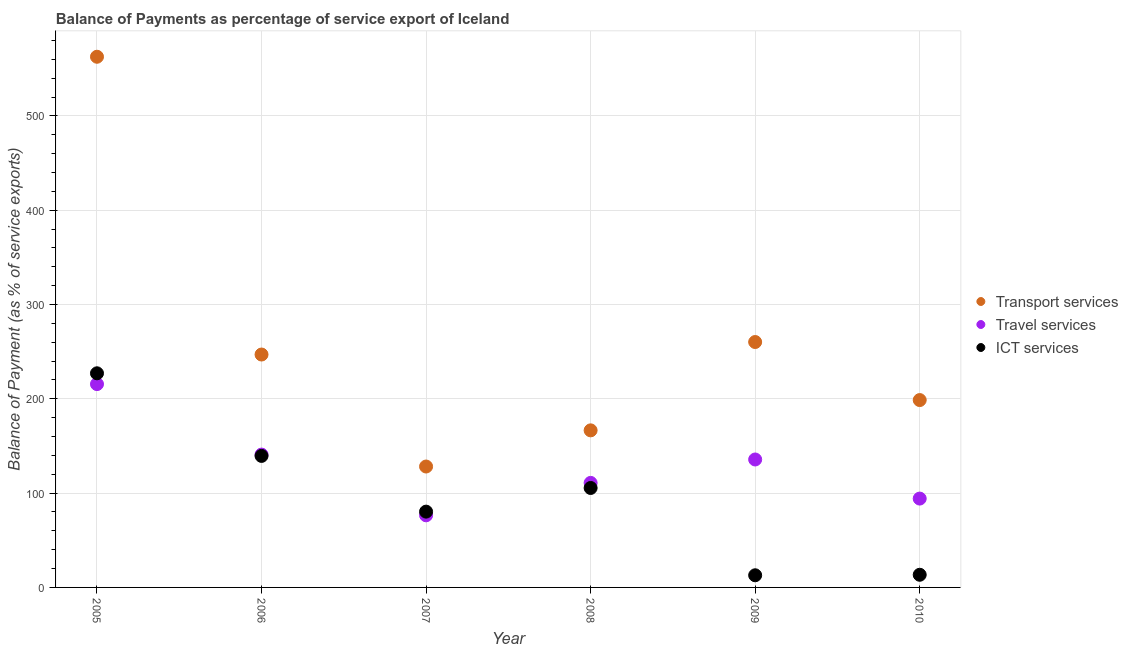How many different coloured dotlines are there?
Your answer should be very brief. 3. Is the number of dotlines equal to the number of legend labels?
Make the answer very short. Yes. What is the balance of payment of ict services in 2006?
Keep it short and to the point. 139.47. Across all years, what is the maximum balance of payment of transport services?
Give a very brief answer. 562.81. Across all years, what is the minimum balance of payment of travel services?
Offer a very short reply. 76.47. What is the total balance of payment of travel services in the graph?
Make the answer very short. 773.76. What is the difference between the balance of payment of ict services in 2008 and that in 2009?
Provide a short and direct response. 92.59. What is the difference between the balance of payment of ict services in 2007 and the balance of payment of travel services in 2008?
Provide a succinct answer. -30.48. What is the average balance of payment of ict services per year?
Your answer should be compact. 96.46. In the year 2010, what is the difference between the balance of payment of ict services and balance of payment of travel services?
Your answer should be compact. -80.8. In how many years, is the balance of payment of travel services greater than 100 %?
Your response must be concise. 4. What is the ratio of the balance of payment of transport services in 2006 to that in 2010?
Your response must be concise. 1.24. What is the difference between the highest and the second highest balance of payment of travel services?
Give a very brief answer. 74.77. What is the difference between the highest and the lowest balance of payment of travel services?
Keep it short and to the point. 139.18. In how many years, is the balance of payment of travel services greater than the average balance of payment of travel services taken over all years?
Keep it short and to the point. 3. How many dotlines are there?
Offer a very short reply. 3. How many years are there in the graph?
Offer a terse response. 6. What is the difference between two consecutive major ticks on the Y-axis?
Your answer should be very brief. 100. Does the graph contain grids?
Provide a short and direct response. Yes. How many legend labels are there?
Keep it short and to the point. 3. How are the legend labels stacked?
Keep it short and to the point. Vertical. What is the title of the graph?
Keep it short and to the point. Balance of Payments as percentage of service export of Iceland. Does "Argument" appear as one of the legend labels in the graph?
Keep it short and to the point. No. What is the label or title of the Y-axis?
Offer a terse response. Balance of Payment (as % of service exports). What is the Balance of Payment (as % of service exports) in Transport services in 2005?
Offer a very short reply. 562.81. What is the Balance of Payment (as % of service exports) in Travel services in 2005?
Keep it short and to the point. 215.64. What is the Balance of Payment (as % of service exports) of ICT services in 2005?
Provide a succinct answer. 227.09. What is the Balance of Payment (as % of service exports) of Transport services in 2006?
Keep it short and to the point. 247. What is the Balance of Payment (as % of service exports) in Travel services in 2006?
Give a very brief answer. 140.88. What is the Balance of Payment (as % of service exports) in ICT services in 2006?
Provide a succinct answer. 139.47. What is the Balance of Payment (as % of service exports) of Transport services in 2007?
Your answer should be compact. 128.23. What is the Balance of Payment (as % of service exports) in Travel services in 2007?
Offer a terse response. 76.47. What is the Balance of Payment (as % of service exports) in ICT services in 2007?
Offer a terse response. 80.38. What is the Balance of Payment (as % of service exports) of Transport services in 2008?
Your response must be concise. 166.58. What is the Balance of Payment (as % of service exports) of Travel services in 2008?
Make the answer very short. 110.86. What is the Balance of Payment (as % of service exports) in ICT services in 2008?
Offer a very short reply. 105.47. What is the Balance of Payment (as % of service exports) in Transport services in 2009?
Give a very brief answer. 260.27. What is the Balance of Payment (as % of service exports) of Travel services in 2009?
Your response must be concise. 135.69. What is the Balance of Payment (as % of service exports) in ICT services in 2009?
Ensure brevity in your answer.  12.89. What is the Balance of Payment (as % of service exports) in Transport services in 2010?
Your answer should be very brief. 198.71. What is the Balance of Payment (as % of service exports) of Travel services in 2010?
Offer a terse response. 94.23. What is the Balance of Payment (as % of service exports) in ICT services in 2010?
Give a very brief answer. 13.43. Across all years, what is the maximum Balance of Payment (as % of service exports) of Transport services?
Offer a very short reply. 562.81. Across all years, what is the maximum Balance of Payment (as % of service exports) in Travel services?
Offer a very short reply. 215.64. Across all years, what is the maximum Balance of Payment (as % of service exports) of ICT services?
Your answer should be very brief. 227.09. Across all years, what is the minimum Balance of Payment (as % of service exports) of Transport services?
Give a very brief answer. 128.23. Across all years, what is the minimum Balance of Payment (as % of service exports) of Travel services?
Provide a succinct answer. 76.47. Across all years, what is the minimum Balance of Payment (as % of service exports) in ICT services?
Offer a very short reply. 12.89. What is the total Balance of Payment (as % of service exports) of Transport services in the graph?
Your response must be concise. 1563.59. What is the total Balance of Payment (as % of service exports) in Travel services in the graph?
Offer a terse response. 773.76. What is the total Balance of Payment (as % of service exports) of ICT services in the graph?
Keep it short and to the point. 578.74. What is the difference between the Balance of Payment (as % of service exports) of Transport services in 2005 and that in 2006?
Offer a terse response. 315.81. What is the difference between the Balance of Payment (as % of service exports) in Travel services in 2005 and that in 2006?
Provide a succinct answer. 74.77. What is the difference between the Balance of Payment (as % of service exports) of ICT services in 2005 and that in 2006?
Your answer should be very brief. 87.62. What is the difference between the Balance of Payment (as % of service exports) in Transport services in 2005 and that in 2007?
Ensure brevity in your answer.  434.58. What is the difference between the Balance of Payment (as % of service exports) in Travel services in 2005 and that in 2007?
Your response must be concise. 139.18. What is the difference between the Balance of Payment (as % of service exports) in ICT services in 2005 and that in 2007?
Keep it short and to the point. 146.71. What is the difference between the Balance of Payment (as % of service exports) in Transport services in 2005 and that in 2008?
Your answer should be very brief. 396.23. What is the difference between the Balance of Payment (as % of service exports) in Travel services in 2005 and that in 2008?
Give a very brief answer. 104.78. What is the difference between the Balance of Payment (as % of service exports) in ICT services in 2005 and that in 2008?
Your answer should be very brief. 121.62. What is the difference between the Balance of Payment (as % of service exports) in Transport services in 2005 and that in 2009?
Your answer should be compact. 302.54. What is the difference between the Balance of Payment (as % of service exports) of Travel services in 2005 and that in 2009?
Offer a very short reply. 79.96. What is the difference between the Balance of Payment (as % of service exports) in ICT services in 2005 and that in 2009?
Offer a terse response. 214.2. What is the difference between the Balance of Payment (as % of service exports) of Transport services in 2005 and that in 2010?
Provide a short and direct response. 364.1. What is the difference between the Balance of Payment (as % of service exports) in Travel services in 2005 and that in 2010?
Offer a very short reply. 121.42. What is the difference between the Balance of Payment (as % of service exports) in ICT services in 2005 and that in 2010?
Your response must be concise. 213.67. What is the difference between the Balance of Payment (as % of service exports) in Transport services in 2006 and that in 2007?
Your response must be concise. 118.77. What is the difference between the Balance of Payment (as % of service exports) of Travel services in 2006 and that in 2007?
Give a very brief answer. 64.41. What is the difference between the Balance of Payment (as % of service exports) in ICT services in 2006 and that in 2007?
Your response must be concise. 59.09. What is the difference between the Balance of Payment (as % of service exports) in Transport services in 2006 and that in 2008?
Your response must be concise. 80.42. What is the difference between the Balance of Payment (as % of service exports) in Travel services in 2006 and that in 2008?
Make the answer very short. 30.02. What is the difference between the Balance of Payment (as % of service exports) in ICT services in 2006 and that in 2008?
Provide a succinct answer. 34. What is the difference between the Balance of Payment (as % of service exports) of Transport services in 2006 and that in 2009?
Ensure brevity in your answer.  -13.27. What is the difference between the Balance of Payment (as % of service exports) of Travel services in 2006 and that in 2009?
Give a very brief answer. 5.19. What is the difference between the Balance of Payment (as % of service exports) in ICT services in 2006 and that in 2009?
Give a very brief answer. 126.59. What is the difference between the Balance of Payment (as % of service exports) of Transport services in 2006 and that in 2010?
Ensure brevity in your answer.  48.29. What is the difference between the Balance of Payment (as % of service exports) in Travel services in 2006 and that in 2010?
Provide a short and direct response. 46.65. What is the difference between the Balance of Payment (as % of service exports) in ICT services in 2006 and that in 2010?
Make the answer very short. 126.05. What is the difference between the Balance of Payment (as % of service exports) of Transport services in 2007 and that in 2008?
Your answer should be compact. -38.35. What is the difference between the Balance of Payment (as % of service exports) of Travel services in 2007 and that in 2008?
Offer a very short reply. -34.39. What is the difference between the Balance of Payment (as % of service exports) in ICT services in 2007 and that in 2008?
Offer a terse response. -25.09. What is the difference between the Balance of Payment (as % of service exports) of Transport services in 2007 and that in 2009?
Your answer should be very brief. -132.04. What is the difference between the Balance of Payment (as % of service exports) in Travel services in 2007 and that in 2009?
Your answer should be compact. -59.22. What is the difference between the Balance of Payment (as % of service exports) in ICT services in 2007 and that in 2009?
Your response must be concise. 67.5. What is the difference between the Balance of Payment (as % of service exports) in Transport services in 2007 and that in 2010?
Give a very brief answer. -70.48. What is the difference between the Balance of Payment (as % of service exports) of Travel services in 2007 and that in 2010?
Your response must be concise. -17.76. What is the difference between the Balance of Payment (as % of service exports) of ICT services in 2007 and that in 2010?
Your answer should be compact. 66.96. What is the difference between the Balance of Payment (as % of service exports) of Transport services in 2008 and that in 2009?
Your answer should be compact. -93.69. What is the difference between the Balance of Payment (as % of service exports) in Travel services in 2008 and that in 2009?
Make the answer very short. -24.83. What is the difference between the Balance of Payment (as % of service exports) in ICT services in 2008 and that in 2009?
Ensure brevity in your answer.  92.59. What is the difference between the Balance of Payment (as % of service exports) in Transport services in 2008 and that in 2010?
Offer a very short reply. -32.13. What is the difference between the Balance of Payment (as % of service exports) in Travel services in 2008 and that in 2010?
Make the answer very short. 16.63. What is the difference between the Balance of Payment (as % of service exports) in ICT services in 2008 and that in 2010?
Keep it short and to the point. 92.05. What is the difference between the Balance of Payment (as % of service exports) in Transport services in 2009 and that in 2010?
Give a very brief answer. 61.56. What is the difference between the Balance of Payment (as % of service exports) of Travel services in 2009 and that in 2010?
Your response must be concise. 41.46. What is the difference between the Balance of Payment (as % of service exports) of ICT services in 2009 and that in 2010?
Ensure brevity in your answer.  -0.54. What is the difference between the Balance of Payment (as % of service exports) in Transport services in 2005 and the Balance of Payment (as % of service exports) in Travel services in 2006?
Provide a short and direct response. 421.93. What is the difference between the Balance of Payment (as % of service exports) of Transport services in 2005 and the Balance of Payment (as % of service exports) of ICT services in 2006?
Make the answer very short. 423.33. What is the difference between the Balance of Payment (as % of service exports) of Travel services in 2005 and the Balance of Payment (as % of service exports) of ICT services in 2006?
Your answer should be very brief. 76.17. What is the difference between the Balance of Payment (as % of service exports) of Transport services in 2005 and the Balance of Payment (as % of service exports) of Travel services in 2007?
Make the answer very short. 486.34. What is the difference between the Balance of Payment (as % of service exports) of Transport services in 2005 and the Balance of Payment (as % of service exports) of ICT services in 2007?
Offer a very short reply. 482.42. What is the difference between the Balance of Payment (as % of service exports) in Travel services in 2005 and the Balance of Payment (as % of service exports) in ICT services in 2007?
Ensure brevity in your answer.  135.26. What is the difference between the Balance of Payment (as % of service exports) of Transport services in 2005 and the Balance of Payment (as % of service exports) of Travel services in 2008?
Offer a very short reply. 451.95. What is the difference between the Balance of Payment (as % of service exports) in Transport services in 2005 and the Balance of Payment (as % of service exports) in ICT services in 2008?
Ensure brevity in your answer.  457.33. What is the difference between the Balance of Payment (as % of service exports) of Travel services in 2005 and the Balance of Payment (as % of service exports) of ICT services in 2008?
Offer a very short reply. 110.17. What is the difference between the Balance of Payment (as % of service exports) of Transport services in 2005 and the Balance of Payment (as % of service exports) of Travel services in 2009?
Keep it short and to the point. 427.12. What is the difference between the Balance of Payment (as % of service exports) of Transport services in 2005 and the Balance of Payment (as % of service exports) of ICT services in 2009?
Your answer should be very brief. 549.92. What is the difference between the Balance of Payment (as % of service exports) of Travel services in 2005 and the Balance of Payment (as % of service exports) of ICT services in 2009?
Offer a terse response. 202.76. What is the difference between the Balance of Payment (as % of service exports) in Transport services in 2005 and the Balance of Payment (as % of service exports) in Travel services in 2010?
Keep it short and to the point. 468.58. What is the difference between the Balance of Payment (as % of service exports) of Transport services in 2005 and the Balance of Payment (as % of service exports) of ICT services in 2010?
Your answer should be compact. 549.38. What is the difference between the Balance of Payment (as % of service exports) of Travel services in 2005 and the Balance of Payment (as % of service exports) of ICT services in 2010?
Your answer should be very brief. 202.22. What is the difference between the Balance of Payment (as % of service exports) in Transport services in 2006 and the Balance of Payment (as % of service exports) in Travel services in 2007?
Your answer should be compact. 170.53. What is the difference between the Balance of Payment (as % of service exports) in Transport services in 2006 and the Balance of Payment (as % of service exports) in ICT services in 2007?
Ensure brevity in your answer.  166.61. What is the difference between the Balance of Payment (as % of service exports) of Travel services in 2006 and the Balance of Payment (as % of service exports) of ICT services in 2007?
Your answer should be very brief. 60.49. What is the difference between the Balance of Payment (as % of service exports) of Transport services in 2006 and the Balance of Payment (as % of service exports) of Travel services in 2008?
Your response must be concise. 136.14. What is the difference between the Balance of Payment (as % of service exports) in Transport services in 2006 and the Balance of Payment (as % of service exports) in ICT services in 2008?
Keep it short and to the point. 141.52. What is the difference between the Balance of Payment (as % of service exports) in Travel services in 2006 and the Balance of Payment (as % of service exports) in ICT services in 2008?
Your answer should be very brief. 35.4. What is the difference between the Balance of Payment (as % of service exports) in Transport services in 2006 and the Balance of Payment (as % of service exports) in Travel services in 2009?
Keep it short and to the point. 111.31. What is the difference between the Balance of Payment (as % of service exports) of Transport services in 2006 and the Balance of Payment (as % of service exports) of ICT services in 2009?
Provide a short and direct response. 234.11. What is the difference between the Balance of Payment (as % of service exports) in Travel services in 2006 and the Balance of Payment (as % of service exports) in ICT services in 2009?
Offer a terse response. 127.99. What is the difference between the Balance of Payment (as % of service exports) of Transport services in 2006 and the Balance of Payment (as % of service exports) of Travel services in 2010?
Offer a terse response. 152.77. What is the difference between the Balance of Payment (as % of service exports) of Transport services in 2006 and the Balance of Payment (as % of service exports) of ICT services in 2010?
Make the answer very short. 233.57. What is the difference between the Balance of Payment (as % of service exports) of Travel services in 2006 and the Balance of Payment (as % of service exports) of ICT services in 2010?
Give a very brief answer. 127.45. What is the difference between the Balance of Payment (as % of service exports) of Transport services in 2007 and the Balance of Payment (as % of service exports) of Travel services in 2008?
Ensure brevity in your answer.  17.37. What is the difference between the Balance of Payment (as % of service exports) of Transport services in 2007 and the Balance of Payment (as % of service exports) of ICT services in 2008?
Provide a succinct answer. 22.75. What is the difference between the Balance of Payment (as % of service exports) in Travel services in 2007 and the Balance of Payment (as % of service exports) in ICT services in 2008?
Give a very brief answer. -29.01. What is the difference between the Balance of Payment (as % of service exports) in Transport services in 2007 and the Balance of Payment (as % of service exports) in Travel services in 2009?
Provide a short and direct response. -7.46. What is the difference between the Balance of Payment (as % of service exports) in Transport services in 2007 and the Balance of Payment (as % of service exports) in ICT services in 2009?
Offer a very short reply. 115.34. What is the difference between the Balance of Payment (as % of service exports) of Travel services in 2007 and the Balance of Payment (as % of service exports) of ICT services in 2009?
Provide a short and direct response. 63.58. What is the difference between the Balance of Payment (as % of service exports) in Transport services in 2007 and the Balance of Payment (as % of service exports) in Travel services in 2010?
Provide a succinct answer. 34. What is the difference between the Balance of Payment (as % of service exports) of Transport services in 2007 and the Balance of Payment (as % of service exports) of ICT services in 2010?
Ensure brevity in your answer.  114.8. What is the difference between the Balance of Payment (as % of service exports) in Travel services in 2007 and the Balance of Payment (as % of service exports) in ICT services in 2010?
Offer a very short reply. 63.04. What is the difference between the Balance of Payment (as % of service exports) of Transport services in 2008 and the Balance of Payment (as % of service exports) of Travel services in 2009?
Provide a succinct answer. 30.9. What is the difference between the Balance of Payment (as % of service exports) of Transport services in 2008 and the Balance of Payment (as % of service exports) of ICT services in 2009?
Provide a short and direct response. 153.69. What is the difference between the Balance of Payment (as % of service exports) in Travel services in 2008 and the Balance of Payment (as % of service exports) in ICT services in 2009?
Your answer should be compact. 97.97. What is the difference between the Balance of Payment (as % of service exports) of Transport services in 2008 and the Balance of Payment (as % of service exports) of Travel services in 2010?
Make the answer very short. 72.36. What is the difference between the Balance of Payment (as % of service exports) of Transport services in 2008 and the Balance of Payment (as % of service exports) of ICT services in 2010?
Provide a succinct answer. 153.16. What is the difference between the Balance of Payment (as % of service exports) of Travel services in 2008 and the Balance of Payment (as % of service exports) of ICT services in 2010?
Offer a terse response. 97.43. What is the difference between the Balance of Payment (as % of service exports) of Transport services in 2009 and the Balance of Payment (as % of service exports) of Travel services in 2010?
Your answer should be compact. 166.04. What is the difference between the Balance of Payment (as % of service exports) of Transport services in 2009 and the Balance of Payment (as % of service exports) of ICT services in 2010?
Your answer should be compact. 246.84. What is the difference between the Balance of Payment (as % of service exports) of Travel services in 2009 and the Balance of Payment (as % of service exports) of ICT services in 2010?
Your answer should be very brief. 122.26. What is the average Balance of Payment (as % of service exports) of Transport services per year?
Give a very brief answer. 260.6. What is the average Balance of Payment (as % of service exports) of Travel services per year?
Your response must be concise. 128.96. What is the average Balance of Payment (as % of service exports) in ICT services per year?
Offer a very short reply. 96.46. In the year 2005, what is the difference between the Balance of Payment (as % of service exports) in Transport services and Balance of Payment (as % of service exports) in Travel services?
Make the answer very short. 347.16. In the year 2005, what is the difference between the Balance of Payment (as % of service exports) in Transport services and Balance of Payment (as % of service exports) in ICT services?
Your answer should be compact. 335.71. In the year 2005, what is the difference between the Balance of Payment (as % of service exports) of Travel services and Balance of Payment (as % of service exports) of ICT services?
Provide a short and direct response. -11.45. In the year 2006, what is the difference between the Balance of Payment (as % of service exports) in Transport services and Balance of Payment (as % of service exports) in Travel services?
Give a very brief answer. 106.12. In the year 2006, what is the difference between the Balance of Payment (as % of service exports) of Transport services and Balance of Payment (as % of service exports) of ICT services?
Your answer should be compact. 107.52. In the year 2006, what is the difference between the Balance of Payment (as % of service exports) of Travel services and Balance of Payment (as % of service exports) of ICT services?
Your answer should be compact. 1.4. In the year 2007, what is the difference between the Balance of Payment (as % of service exports) of Transport services and Balance of Payment (as % of service exports) of Travel services?
Keep it short and to the point. 51.76. In the year 2007, what is the difference between the Balance of Payment (as % of service exports) in Transport services and Balance of Payment (as % of service exports) in ICT services?
Ensure brevity in your answer.  47.84. In the year 2007, what is the difference between the Balance of Payment (as % of service exports) of Travel services and Balance of Payment (as % of service exports) of ICT services?
Give a very brief answer. -3.92. In the year 2008, what is the difference between the Balance of Payment (as % of service exports) of Transport services and Balance of Payment (as % of service exports) of Travel services?
Ensure brevity in your answer.  55.72. In the year 2008, what is the difference between the Balance of Payment (as % of service exports) of Transport services and Balance of Payment (as % of service exports) of ICT services?
Make the answer very short. 61.11. In the year 2008, what is the difference between the Balance of Payment (as % of service exports) of Travel services and Balance of Payment (as % of service exports) of ICT services?
Your answer should be very brief. 5.39. In the year 2009, what is the difference between the Balance of Payment (as % of service exports) in Transport services and Balance of Payment (as % of service exports) in Travel services?
Your response must be concise. 124.58. In the year 2009, what is the difference between the Balance of Payment (as % of service exports) of Transport services and Balance of Payment (as % of service exports) of ICT services?
Your answer should be compact. 247.38. In the year 2009, what is the difference between the Balance of Payment (as % of service exports) in Travel services and Balance of Payment (as % of service exports) in ICT services?
Ensure brevity in your answer.  122.8. In the year 2010, what is the difference between the Balance of Payment (as % of service exports) in Transport services and Balance of Payment (as % of service exports) in Travel services?
Provide a short and direct response. 104.48. In the year 2010, what is the difference between the Balance of Payment (as % of service exports) in Transport services and Balance of Payment (as % of service exports) in ICT services?
Provide a succinct answer. 185.28. In the year 2010, what is the difference between the Balance of Payment (as % of service exports) of Travel services and Balance of Payment (as % of service exports) of ICT services?
Provide a succinct answer. 80.8. What is the ratio of the Balance of Payment (as % of service exports) of Transport services in 2005 to that in 2006?
Your answer should be compact. 2.28. What is the ratio of the Balance of Payment (as % of service exports) of Travel services in 2005 to that in 2006?
Your answer should be compact. 1.53. What is the ratio of the Balance of Payment (as % of service exports) in ICT services in 2005 to that in 2006?
Your answer should be very brief. 1.63. What is the ratio of the Balance of Payment (as % of service exports) of Transport services in 2005 to that in 2007?
Make the answer very short. 4.39. What is the ratio of the Balance of Payment (as % of service exports) of Travel services in 2005 to that in 2007?
Your answer should be compact. 2.82. What is the ratio of the Balance of Payment (as % of service exports) in ICT services in 2005 to that in 2007?
Offer a terse response. 2.83. What is the ratio of the Balance of Payment (as % of service exports) of Transport services in 2005 to that in 2008?
Your answer should be very brief. 3.38. What is the ratio of the Balance of Payment (as % of service exports) of Travel services in 2005 to that in 2008?
Your answer should be compact. 1.95. What is the ratio of the Balance of Payment (as % of service exports) of ICT services in 2005 to that in 2008?
Provide a short and direct response. 2.15. What is the ratio of the Balance of Payment (as % of service exports) of Transport services in 2005 to that in 2009?
Make the answer very short. 2.16. What is the ratio of the Balance of Payment (as % of service exports) in Travel services in 2005 to that in 2009?
Give a very brief answer. 1.59. What is the ratio of the Balance of Payment (as % of service exports) in ICT services in 2005 to that in 2009?
Your answer should be compact. 17.62. What is the ratio of the Balance of Payment (as % of service exports) in Transport services in 2005 to that in 2010?
Ensure brevity in your answer.  2.83. What is the ratio of the Balance of Payment (as % of service exports) in Travel services in 2005 to that in 2010?
Ensure brevity in your answer.  2.29. What is the ratio of the Balance of Payment (as % of service exports) of ICT services in 2005 to that in 2010?
Give a very brief answer. 16.91. What is the ratio of the Balance of Payment (as % of service exports) of Transport services in 2006 to that in 2007?
Offer a terse response. 1.93. What is the ratio of the Balance of Payment (as % of service exports) of Travel services in 2006 to that in 2007?
Make the answer very short. 1.84. What is the ratio of the Balance of Payment (as % of service exports) in ICT services in 2006 to that in 2007?
Your answer should be very brief. 1.74. What is the ratio of the Balance of Payment (as % of service exports) of Transport services in 2006 to that in 2008?
Provide a succinct answer. 1.48. What is the ratio of the Balance of Payment (as % of service exports) in Travel services in 2006 to that in 2008?
Your response must be concise. 1.27. What is the ratio of the Balance of Payment (as % of service exports) in ICT services in 2006 to that in 2008?
Offer a terse response. 1.32. What is the ratio of the Balance of Payment (as % of service exports) of Transport services in 2006 to that in 2009?
Offer a very short reply. 0.95. What is the ratio of the Balance of Payment (as % of service exports) of Travel services in 2006 to that in 2009?
Ensure brevity in your answer.  1.04. What is the ratio of the Balance of Payment (as % of service exports) of ICT services in 2006 to that in 2009?
Your answer should be very brief. 10.82. What is the ratio of the Balance of Payment (as % of service exports) in Transport services in 2006 to that in 2010?
Provide a short and direct response. 1.24. What is the ratio of the Balance of Payment (as % of service exports) in Travel services in 2006 to that in 2010?
Your response must be concise. 1.5. What is the ratio of the Balance of Payment (as % of service exports) in ICT services in 2006 to that in 2010?
Provide a short and direct response. 10.39. What is the ratio of the Balance of Payment (as % of service exports) in Transport services in 2007 to that in 2008?
Your response must be concise. 0.77. What is the ratio of the Balance of Payment (as % of service exports) in Travel services in 2007 to that in 2008?
Give a very brief answer. 0.69. What is the ratio of the Balance of Payment (as % of service exports) of ICT services in 2007 to that in 2008?
Keep it short and to the point. 0.76. What is the ratio of the Balance of Payment (as % of service exports) in Transport services in 2007 to that in 2009?
Offer a very short reply. 0.49. What is the ratio of the Balance of Payment (as % of service exports) in Travel services in 2007 to that in 2009?
Provide a short and direct response. 0.56. What is the ratio of the Balance of Payment (as % of service exports) in ICT services in 2007 to that in 2009?
Your answer should be compact. 6.24. What is the ratio of the Balance of Payment (as % of service exports) in Transport services in 2007 to that in 2010?
Your response must be concise. 0.65. What is the ratio of the Balance of Payment (as % of service exports) of Travel services in 2007 to that in 2010?
Offer a terse response. 0.81. What is the ratio of the Balance of Payment (as % of service exports) of ICT services in 2007 to that in 2010?
Provide a succinct answer. 5.99. What is the ratio of the Balance of Payment (as % of service exports) of Transport services in 2008 to that in 2009?
Ensure brevity in your answer.  0.64. What is the ratio of the Balance of Payment (as % of service exports) in Travel services in 2008 to that in 2009?
Provide a succinct answer. 0.82. What is the ratio of the Balance of Payment (as % of service exports) in ICT services in 2008 to that in 2009?
Your answer should be compact. 8.18. What is the ratio of the Balance of Payment (as % of service exports) in Transport services in 2008 to that in 2010?
Your answer should be compact. 0.84. What is the ratio of the Balance of Payment (as % of service exports) of Travel services in 2008 to that in 2010?
Ensure brevity in your answer.  1.18. What is the ratio of the Balance of Payment (as % of service exports) in ICT services in 2008 to that in 2010?
Keep it short and to the point. 7.86. What is the ratio of the Balance of Payment (as % of service exports) in Transport services in 2009 to that in 2010?
Your answer should be compact. 1.31. What is the ratio of the Balance of Payment (as % of service exports) of Travel services in 2009 to that in 2010?
Ensure brevity in your answer.  1.44. What is the ratio of the Balance of Payment (as % of service exports) in ICT services in 2009 to that in 2010?
Make the answer very short. 0.96. What is the difference between the highest and the second highest Balance of Payment (as % of service exports) in Transport services?
Your answer should be very brief. 302.54. What is the difference between the highest and the second highest Balance of Payment (as % of service exports) of Travel services?
Provide a succinct answer. 74.77. What is the difference between the highest and the second highest Balance of Payment (as % of service exports) in ICT services?
Offer a very short reply. 87.62. What is the difference between the highest and the lowest Balance of Payment (as % of service exports) of Transport services?
Your answer should be very brief. 434.58. What is the difference between the highest and the lowest Balance of Payment (as % of service exports) of Travel services?
Provide a short and direct response. 139.18. What is the difference between the highest and the lowest Balance of Payment (as % of service exports) in ICT services?
Offer a very short reply. 214.2. 